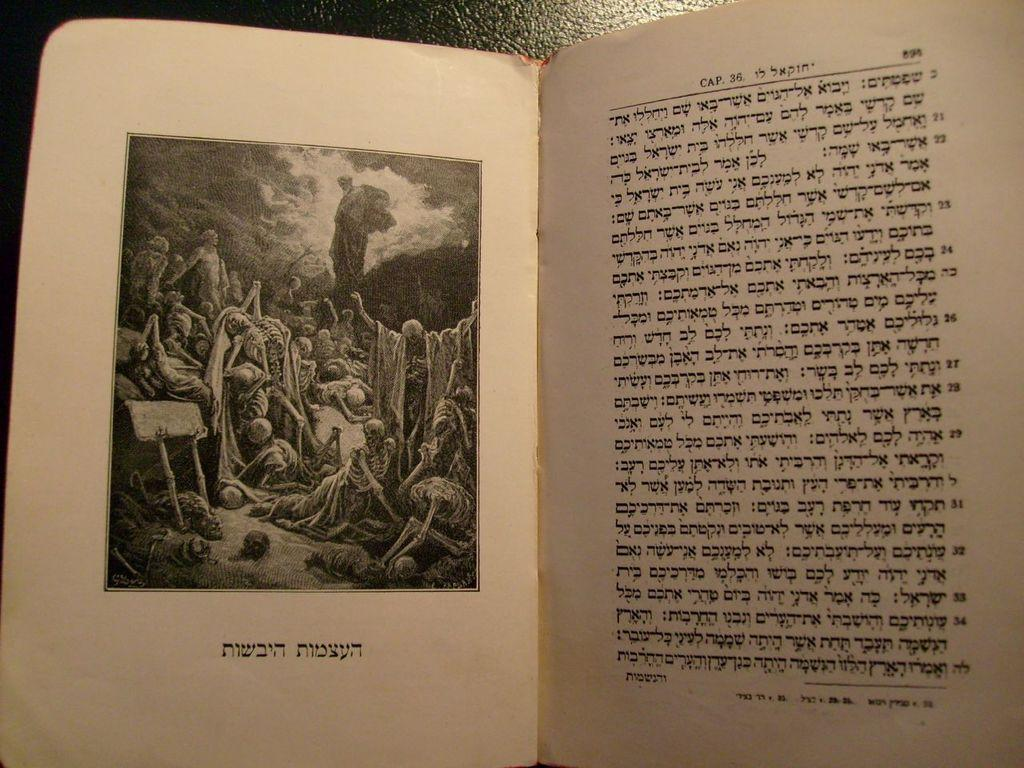<image>
Write a terse but informative summary of the picture. A book is open to a section titled Cap. 36. 